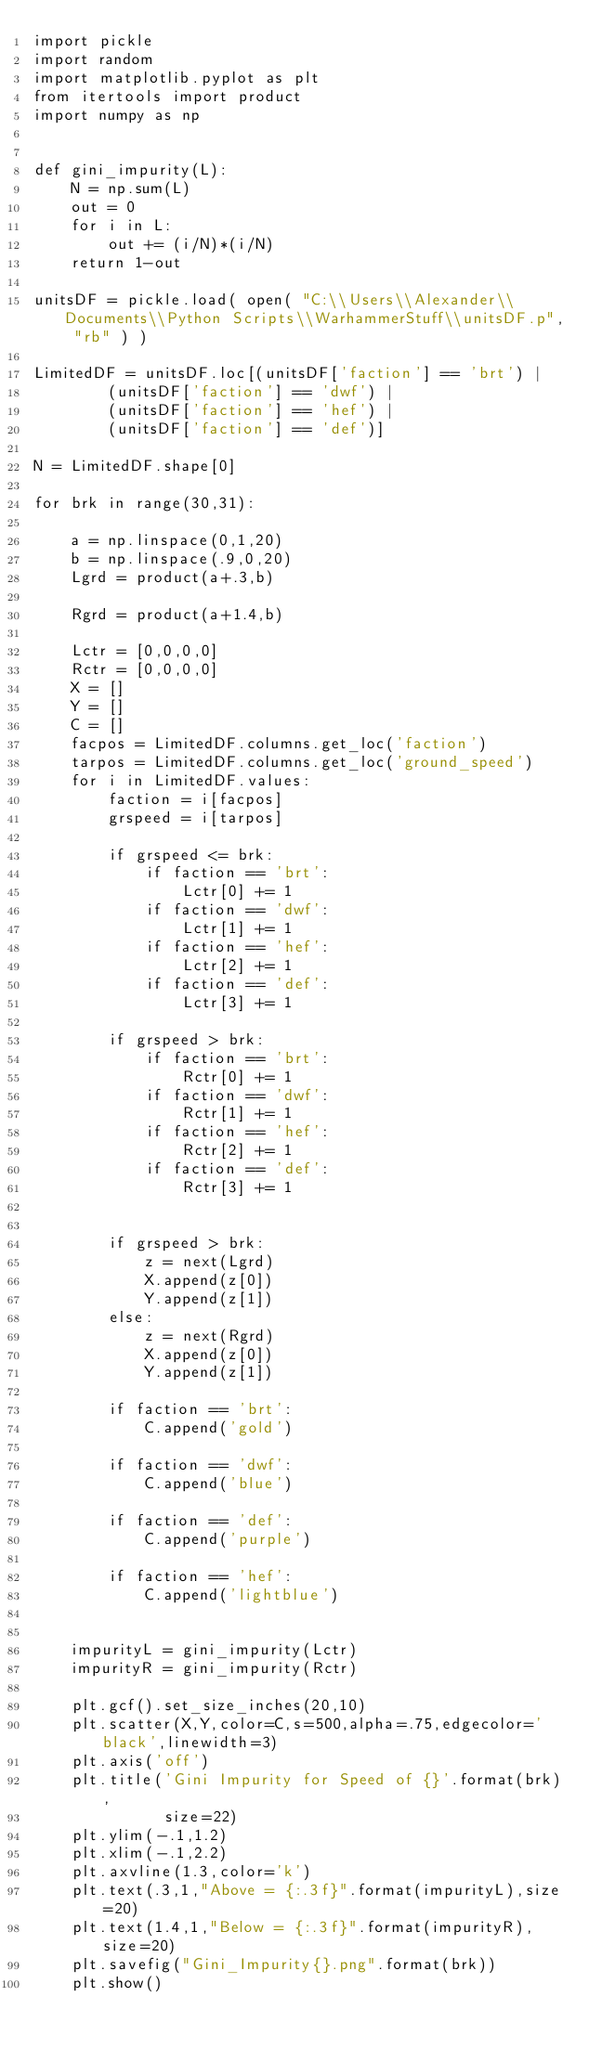Convert code to text. <code><loc_0><loc_0><loc_500><loc_500><_Python_>import pickle
import random
import matplotlib.pyplot as plt
from itertools import product
import numpy as np


def gini_impurity(L):
    N = np.sum(L)
    out = 0
    for i in L:
        out += (i/N)*(i/N)
    return 1-out

unitsDF = pickle.load( open( "C:\\Users\\Alexander\\Documents\\Python Scripts\\WarhammerStuff\\unitsDF.p", "rb" ) )

LimitedDF = unitsDF.loc[(unitsDF['faction'] == 'brt') | 
        (unitsDF['faction'] == 'dwf') |
        (unitsDF['faction'] == 'hef') |
        (unitsDF['faction'] == 'def')]

N = LimitedDF.shape[0]

for brk in range(30,31):
    
    a = np.linspace(0,1,20)
    b = np.linspace(.9,0,20)
    Lgrd = product(a+.3,b)
    
    Rgrd = product(a+1.4,b)
    
    Lctr = [0,0,0,0]
    Rctr = [0,0,0,0]
    X = []
    Y = []
    C = []
    facpos = LimitedDF.columns.get_loc('faction')
    tarpos = LimitedDF.columns.get_loc('ground_speed')
    for i in LimitedDF.values:
        faction = i[facpos]
        grspeed = i[tarpos]
        
        if grspeed <= brk:
            if faction == 'brt':
                Lctr[0] += 1
            if faction == 'dwf':
                Lctr[1] += 1
            if faction == 'hef':
                Lctr[2] += 1
            if faction == 'def':
                Lctr[3] += 1

        if grspeed > brk:
            if faction == 'brt':
                Rctr[0] += 1
            if faction == 'dwf':
                Rctr[1] += 1
            if faction == 'hef':
                Rctr[2] += 1
            if faction == 'def':
                Rctr[3] += 1
        
        
        if grspeed > brk:
            z = next(Lgrd)
            X.append(z[0])
            Y.append(z[1])
        else:
            z = next(Rgrd)
            X.append(z[0])
            Y.append(z[1])
        
        if faction == 'brt':
            C.append('gold')
            
        if faction == 'dwf':
            C.append('blue')
            
        if faction == 'def':
            C.append('purple')
    
        if faction == 'hef':
            C.append('lightblue')
            
            
    impurityL = gini_impurity(Lctr)
    impurityR = gini_impurity(Rctr)
    
    plt.gcf().set_size_inches(20,10)        
    plt.scatter(X,Y,color=C,s=500,alpha=.75,edgecolor='black',linewidth=3)
    plt.axis('off')
    plt.title('Gini Impurity for Speed of {}'.format(brk),
              size=22)
    plt.ylim(-.1,1.2)
    plt.xlim(-.1,2.2)
    plt.axvline(1.3,color='k')
    plt.text(.3,1,"Above = {:.3f}".format(impurityL),size=20)
    plt.text(1.4,1,"Below = {:.3f}".format(impurityR),size=20)
    plt.savefig("Gini_Impurity{}.png".format(brk))
    plt.show()</code> 